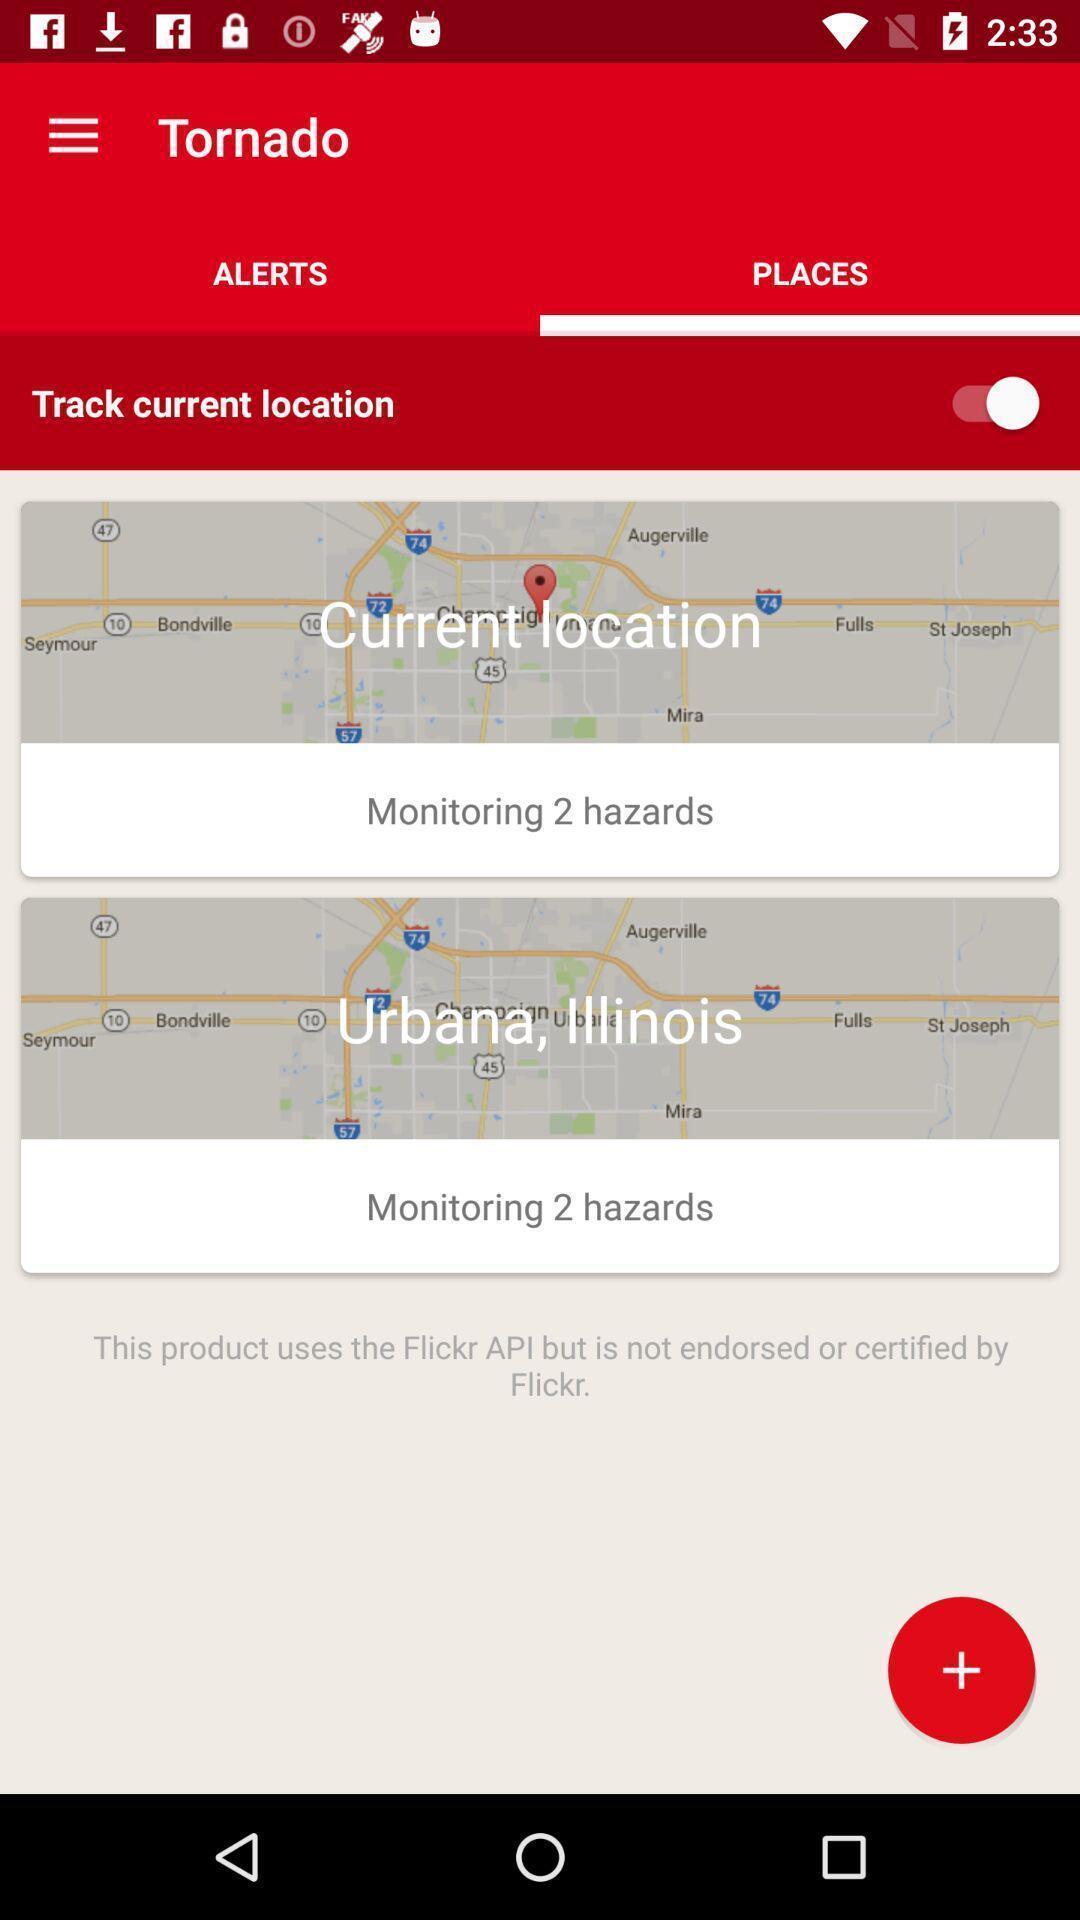Summarize the main components in this picture. Screen shows different places of location. 